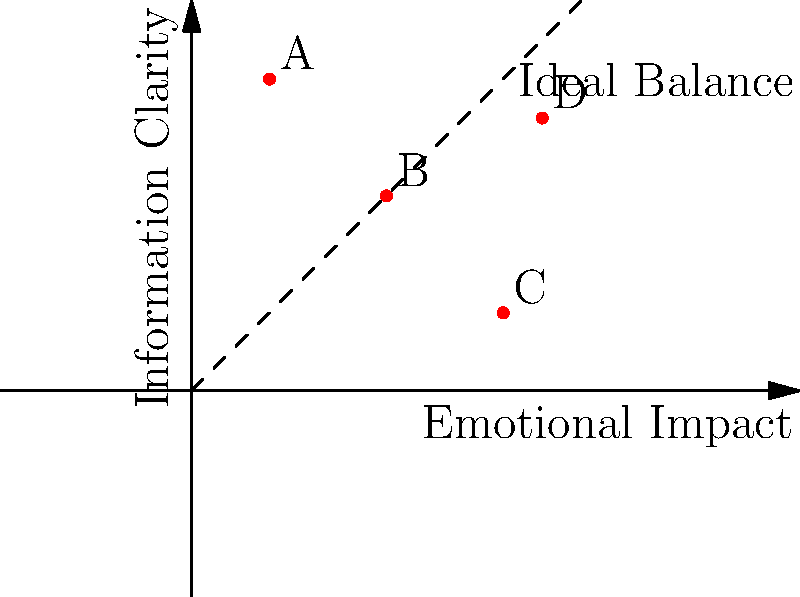In the context of visual storytelling techniques for activist documentaries, which point on the graph represents the most effective approach according to Sholette's theories on artivism? To answer this question, we need to consider Sholette's theories on artivism and apply them to the graph:

1. The x-axis represents "Emotional Impact," which is crucial for engaging viewers and inspiring action.
2. The y-axis represents "Information Clarity," essential for educating the audience about the activist cause.
3. The dashed line represents the ideal balance between emotional impact and information clarity.

Sholette's work emphasizes the importance of balancing artistic expression with activist goals. In the context of visual storytelling for documentaries, this translates to:

4. Point A (0.2, 0.8): High information clarity but low emotional impact. Too didactic, may not engage viewers emotionally.
5. Point B (0.5, 0.5): Balanced, but not maximizing either aspect. Could be more effective.
6. Point C (0.8, 0.2): High emotional impact but low information clarity. May stir emotions but fail to convey the message clearly.
7. Point D (0.9, 0.7): High emotional impact and relatively high information clarity. Closest to the ideal balance line.

Given Sholette's emphasis on both artistic impact and activist efficacy, point D represents the most effective approach. It achieves a high emotional impact while maintaining strong information clarity, aligning closely with the ideal balance line.
Answer: D 